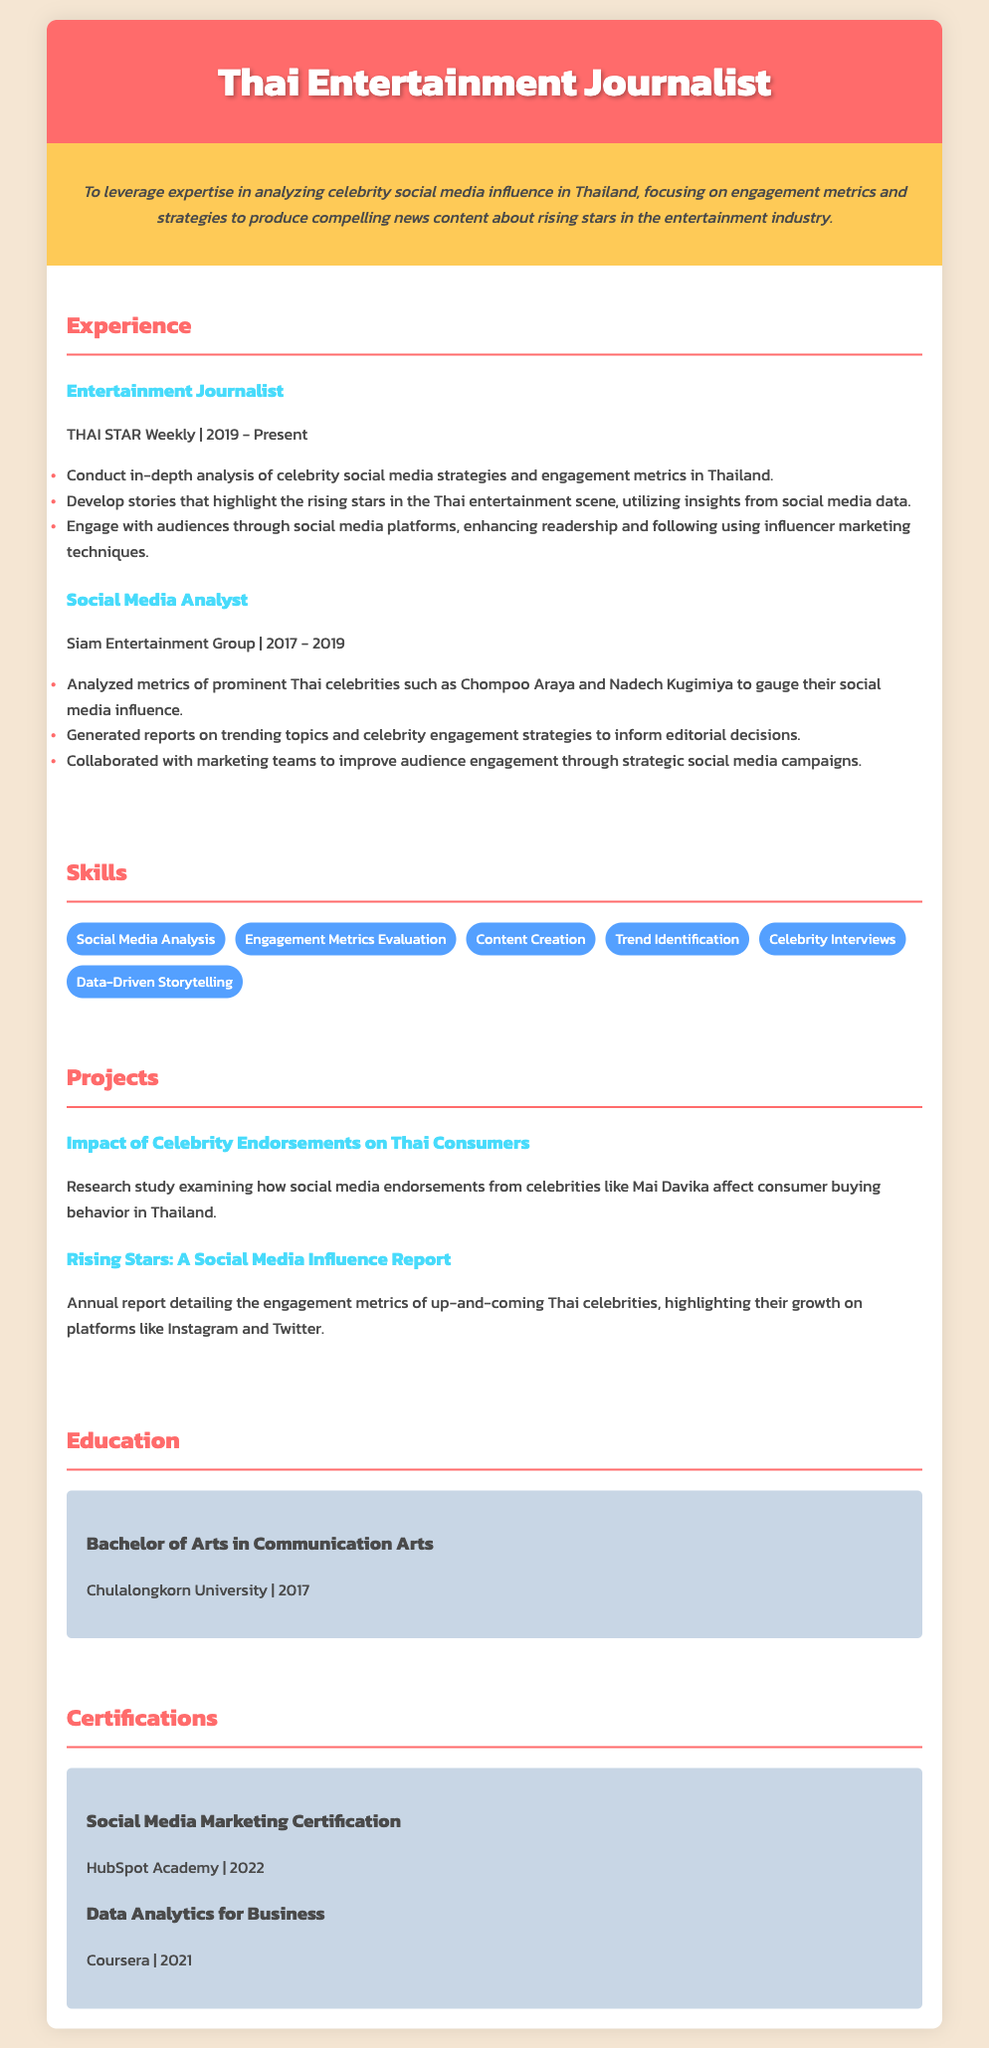what is the current position held by the journalist? The document states the current position as "Entertainment Journalist."
Answer: Entertainment Journalist which organization has the journalist been with since 2019? The CV mentions that the journalist has been with THAI STAR Weekly since 2019.
Answer: THAI STAR Weekly what year did the journalist graduate from university? The document lists the graduation year as 2017.
Answer: 2017 how many years did the journalist work as a Social Media Analyst? The timeline shows that the journalist worked from 2017 to 2019, which is 2 years.
Answer: 2 years what is one of the skills listed in the CV? The document includes a list of skills, one being "Data-Driven Storytelling."
Answer: Data-Driven Storytelling what was the focus of the project titled "Rising Stars: A Social Media Influence Report"? The project details that it focuses on engagement metrics of up-and-coming Thai celebrities.
Answer: engagement metrics of up-and-coming Thai celebrities how many certifications are listed in the document? The CV presents a total of two certifications.
Answer: 2 which university did the journalist attend for their degree? The document specifies Chulalongkorn University as the university attended.
Answer: Chulalongkorn University what is the main objective stated in the CV? The objective centers around analyzing celebrity social media influence in Thailand.
Answer: analyzing celebrity social media influence in Thailand 